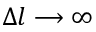Convert formula to latex. <formula><loc_0><loc_0><loc_500><loc_500>\Delta l \longrightarrow \infty</formula> 